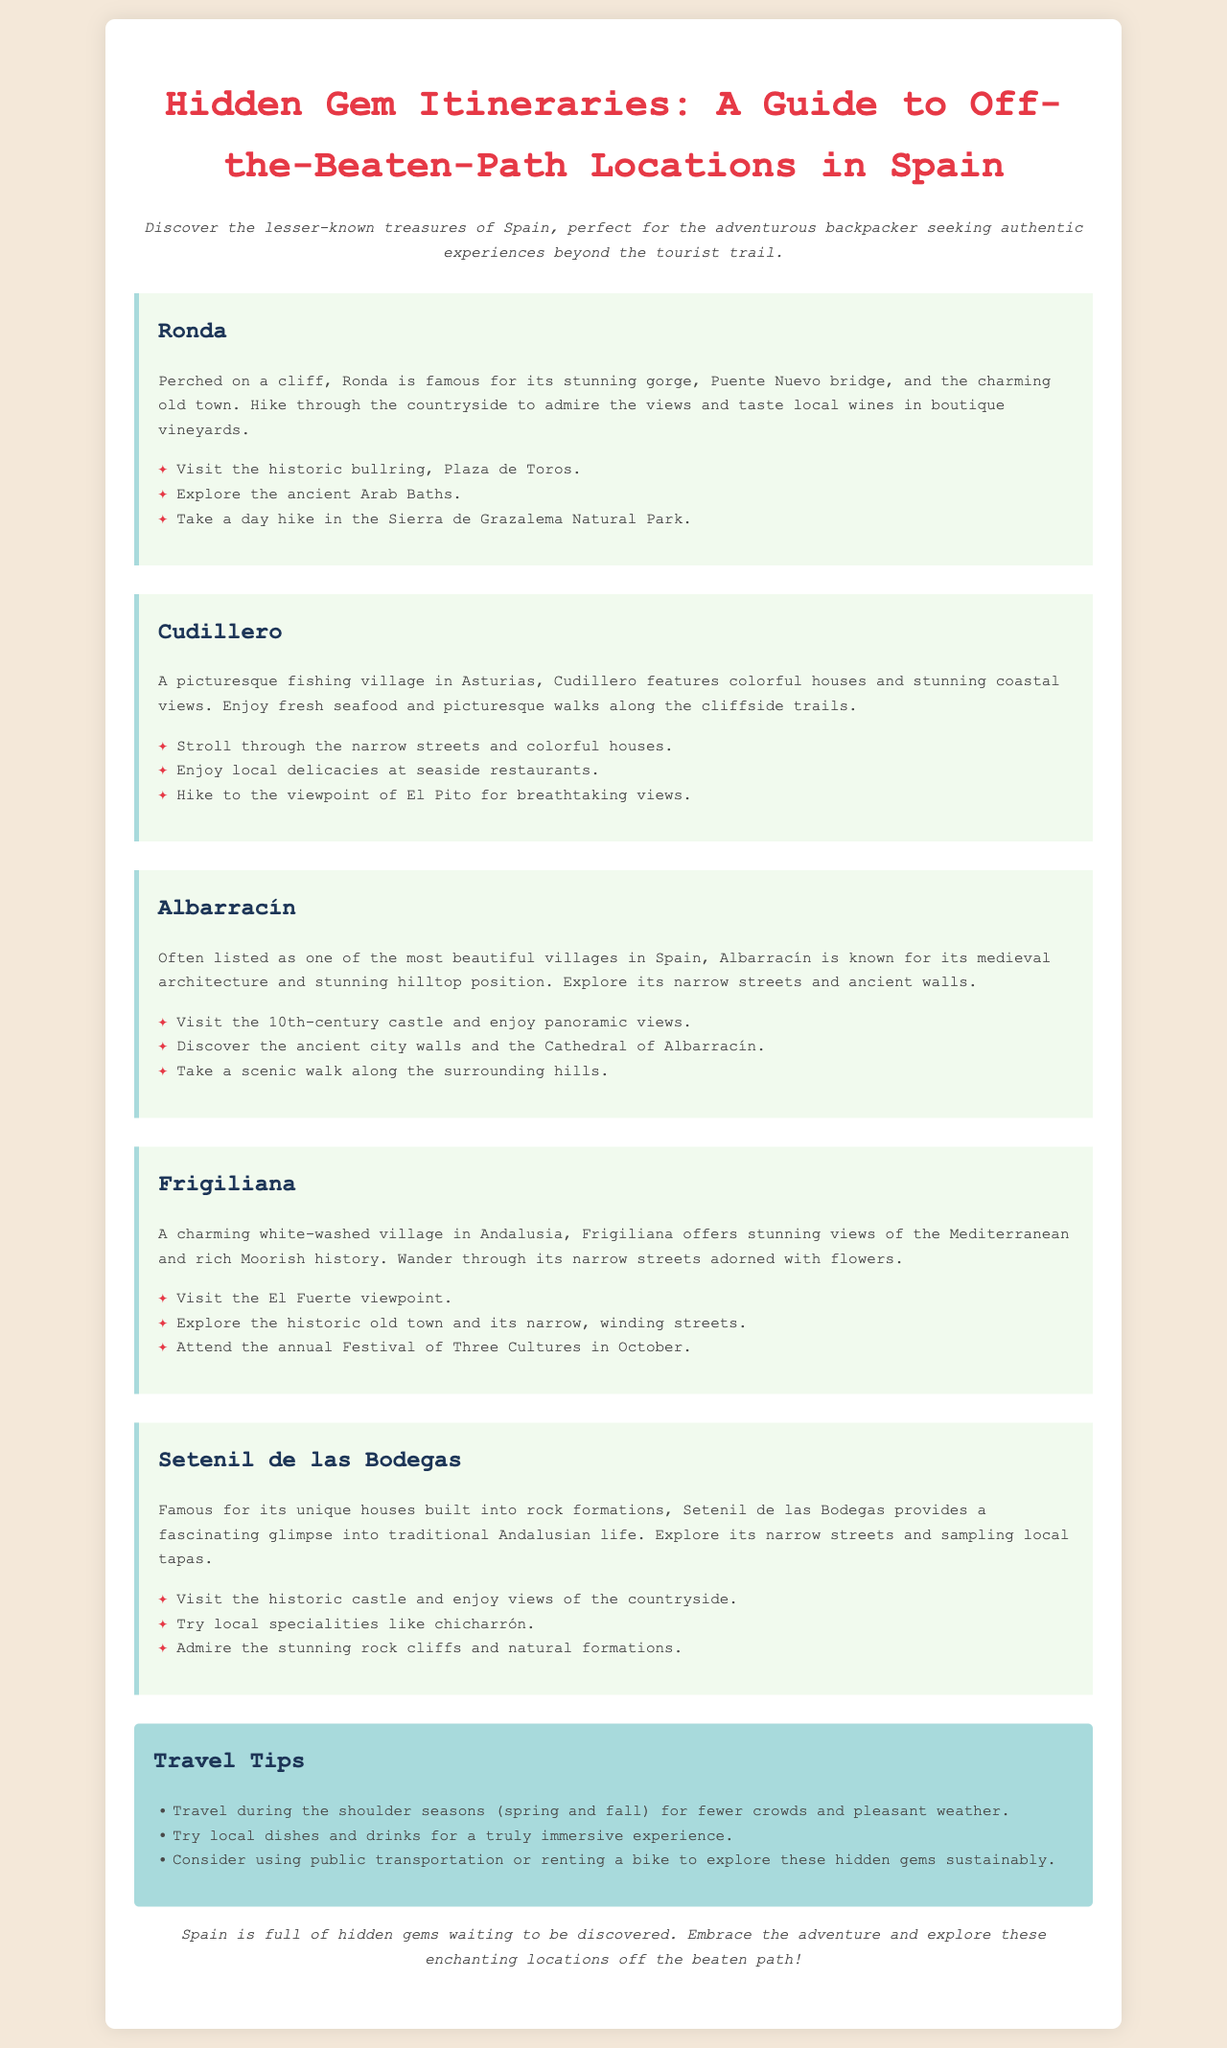What is the title of the brochure? The title is prominently displayed at the top of the document.
Answer: Hidden Gem Itineraries: A Guide to Off-the-Beaten-Path Locations in Spain How many itineraries are provided in the document? The itineraries are listed sequentially, and can be counted.
Answer: Five Which location is famous for its unique houses built into rock formations? This information is mentioned in the description of the relevant location.
Answer: Setenil de las Bodegas What is a recommended activity to do in Ronda? The activities are listed under the highlights section for Ronda.
Answer: Take a day hike in the Sierra de Grazalema Natural Park What should travelers try to enjoy a truly immersive experience? The document provides specific advice on local experiences in its tips section.
Answer: Local dishes and drinks 